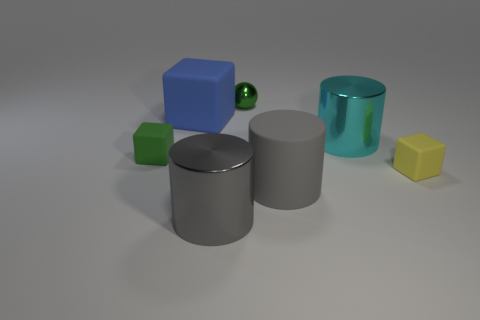Add 2 tiny yellow rubber blocks. How many objects exist? 9 Subtract all cylinders. How many objects are left? 4 Add 6 tiny brown metal spheres. How many tiny brown metal spheres exist? 6 Subtract 0 gray spheres. How many objects are left? 7 Subtract all yellow spheres. Subtract all large gray cylinders. How many objects are left? 5 Add 6 big metallic cylinders. How many big metallic cylinders are left? 8 